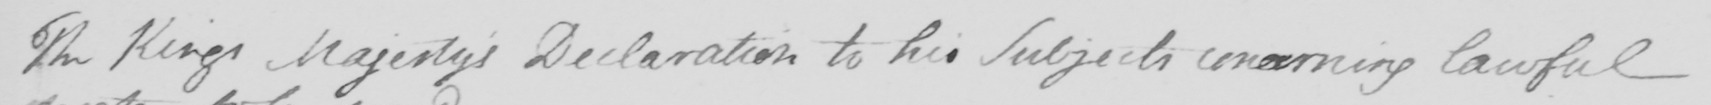Can you read and transcribe this handwriting? The King ' s Majesty ' s Declaration to his subjects concerning lawful 